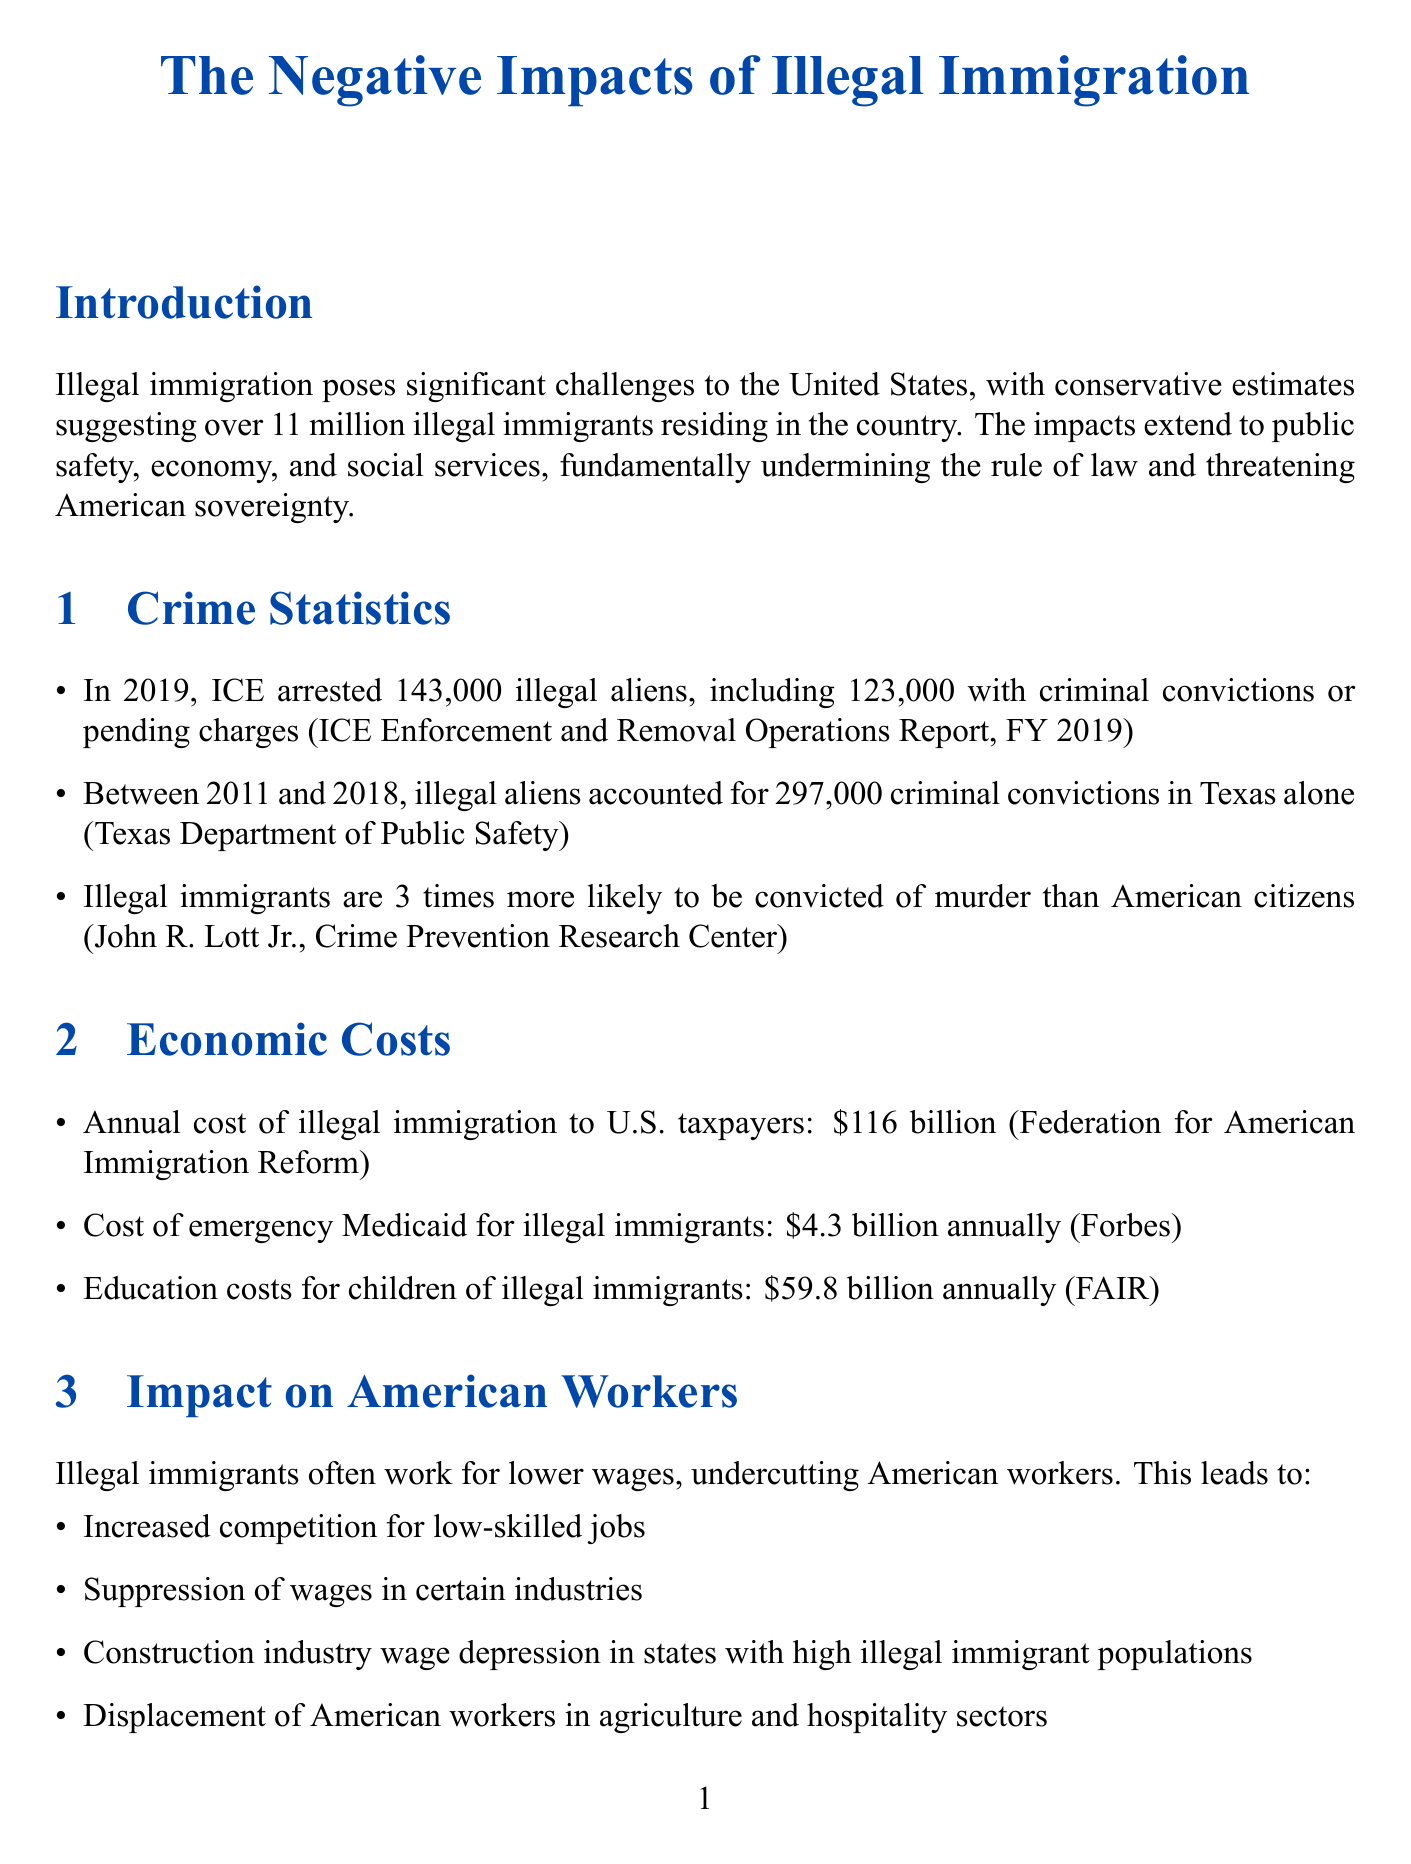What is the estimated number of illegal immigrants in the U.S.? The document states that conservative estimates suggest over 11 million illegal immigrants reside in the country.
Answer: over 11 million Which department reported that illegal aliens accounted for 297,000 criminal convictions in Texas? The statistic is sourced from the Texas Department of Public Safety.
Answer: Texas Department of Public Safety How much does illegal immigration cost U.S. taxpayers annually? The report mentions that the annual cost of illegal immigration to U.S. taxpayers is $116 billion.
Answer: $116 billion What is one proposed solution to combat illegal immigration? The document lists proposed measures including completing the border wall.
Answer: completing the border wall How many illegal aliens did ICE arrest in 2019? The report states that ICE arrested 143,000 illegal aliens in 2019.
Answer: 143,000 What are two affected areas due to the strain on public services? Examples of affected areas include emergency rooms and public schools.
Answer: emergency rooms, public schools What is a key point regarding the impact of illegal immigration on American workers? The document highlights that illegal immigrants often work for lower wages, undercutting American workers.
Answer: undercutting American workers Which gang's activity is linked to illegal immigration? The report mentions MS-13 gang activity in relation to illegal immigration.
Answer: MS-13 gang How much does emergency Medicaid for illegal immigrants cost annually? The document states the cost of emergency Medicaid for illegal immigrants is $4.3 billion annually.
Answer: $4.3 billion 